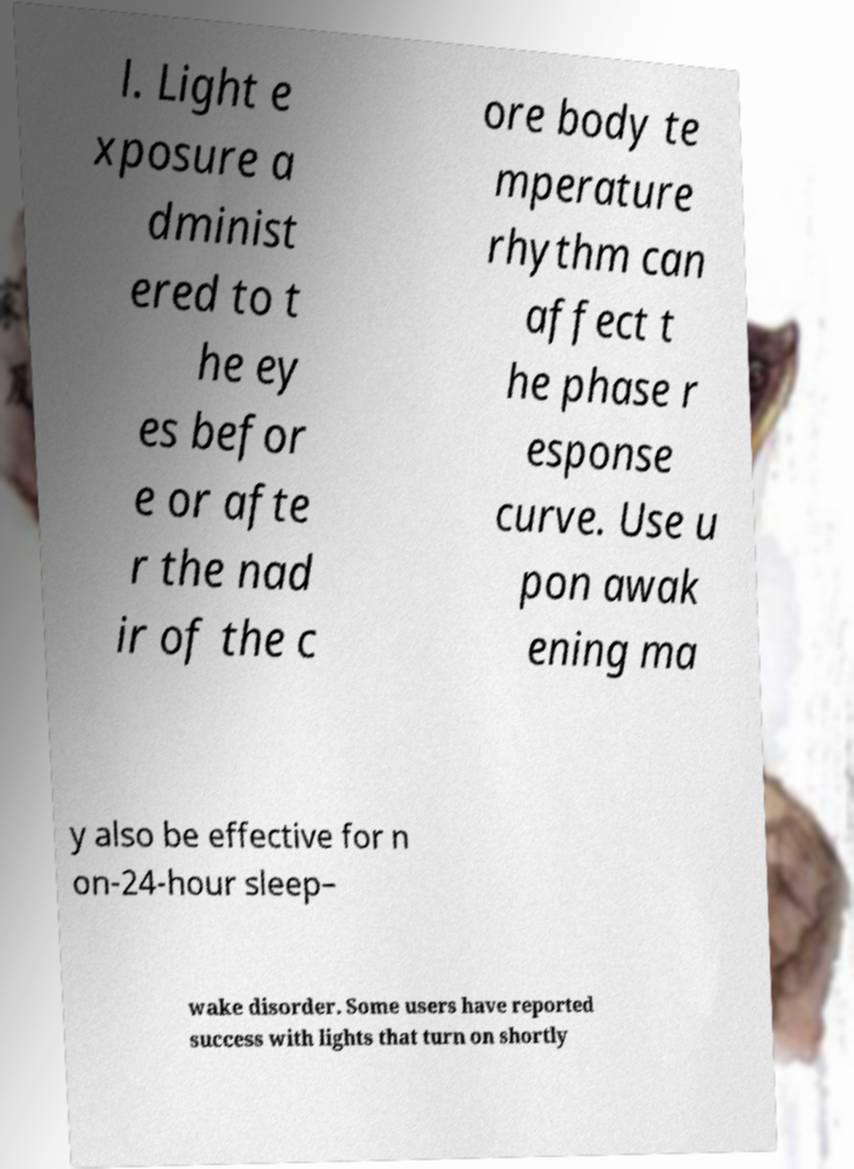Could you extract and type out the text from this image? l. Light e xposure a dminist ered to t he ey es befor e or afte r the nad ir of the c ore body te mperature rhythm can affect t he phase r esponse curve. Use u pon awak ening ma y also be effective for n on-24-hour sleep– wake disorder. Some users have reported success with lights that turn on shortly 